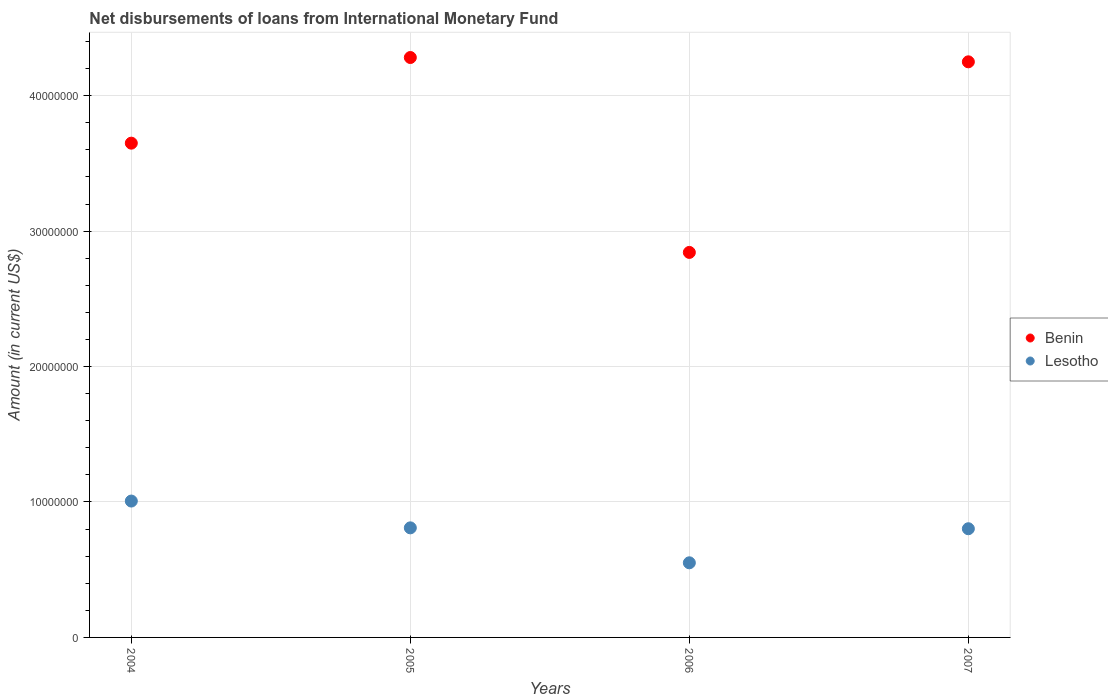Is the number of dotlines equal to the number of legend labels?
Provide a succinct answer. Yes. What is the amount of loans disbursed in Lesotho in 2006?
Ensure brevity in your answer.  5.51e+06. Across all years, what is the maximum amount of loans disbursed in Benin?
Offer a terse response. 4.28e+07. Across all years, what is the minimum amount of loans disbursed in Lesotho?
Give a very brief answer. 5.51e+06. What is the total amount of loans disbursed in Benin in the graph?
Provide a short and direct response. 1.50e+08. What is the difference between the amount of loans disbursed in Lesotho in 2004 and that in 2006?
Keep it short and to the point. 4.56e+06. What is the difference between the amount of loans disbursed in Lesotho in 2004 and the amount of loans disbursed in Benin in 2005?
Your answer should be very brief. -3.28e+07. What is the average amount of loans disbursed in Lesotho per year?
Ensure brevity in your answer.  7.92e+06. In the year 2005, what is the difference between the amount of loans disbursed in Benin and amount of loans disbursed in Lesotho?
Your answer should be very brief. 3.47e+07. In how many years, is the amount of loans disbursed in Benin greater than 42000000 US$?
Provide a succinct answer. 2. What is the ratio of the amount of loans disbursed in Lesotho in 2005 to that in 2006?
Give a very brief answer. 1.47. Is the amount of loans disbursed in Benin in 2006 less than that in 2007?
Provide a short and direct response. Yes. Is the difference between the amount of loans disbursed in Benin in 2004 and 2006 greater than the difference between the amount of loans disbursed in Lesotho in 2004 and 2006?
Offer a terse response. Yes. What is the difference between the highest and the second highest amount of loans disbursed in Benin?
Offer a terse response. 3.18e+05. What is the difference between the highest and the lowest amount of loans disbursed in Benin?
Your answer should be compact. 1.44e+07. In how many years, is the amount of loans disbursed in Benin greater than the average amount of loans disbursed in Benin taken over all years?
Give a very brief answer. 2. Is the amount of loans disbursed in Lesotho strictly greater than the amount of loans disbursed in Benin over the years?
Keep it short and to the point. No. How many dotlines are there?
Your answer should be compact. 2. What is the difference between two consecutive major ticks on the Y-axis?
Your answer should be very brief. 1.00e+07. Does the graph contain any zero values?
Your response must be concise. No. Does the graph contain grids?
Your answer should be compact. Yes. How many legend labels are there?
Your response must be concise. 2. How are the legend labels stacked?
Make the answer very short. Vertical. What is the title of the graph?
Offer a very short reply. Net disbursements of loans from International Monetary Fund. Does "Rwanda" appear as one of the legend labels in the graph?
Give a very brief answer. No. What is the label or title of the Y-axis?
Offer a terse response. Amount (in current US$). What is the Amount (in current US$) in Benin in 2004?
Ensure brevity in your answer.  3.65e+07. What is the Amount (in current US$) of Lesotho in 2004?
Offer a terse response. 1.01e+07. What is the Amount (in current US$) in Benin in 2005?
Provide a succinct answer. 4.28e+07. What is the Amount (in current US$) in Lesotho in 2005?
Your answer should be very brief. 8.09e+06. What is the Amount (in current US$) in Benin in 2006?
Provide a succinct answer. 2.84e+07. What is the Amount (in current US$) of Lesotho in 2006?
Your answer should be compact. 5.51e+06. What is the Amount (in current US$) of Benin in 2007?
Give a very brief answer. 4.25e+07. What is the Amount (in current US$) of Lesotho in 2007?
Your answer should be very brief. 8.02e+06. Across all years, what is the maximum Amount (in current US$) of Benin?
Make the answer very short. 4.28e+07. Across all years, what is the maximum Amount (in current US$) of Lesotho?
Offer a very short reply. 1.01e+07. Across all years, what is the minimum Amount (in current US$) of Benin?
Your response must be concise. 2.84e+07. Across all years, what is the minimum Amount (in current US$) of Lesotho?
Provide a short and direct response. 5.51e+06. What is the total Amount (in current US$) of Benin in the graph?
Your response must be concise. 1.50e+08. What is the total Amount (in current US$) in Lesotho in the graph?
Provide a succinct answer. 3.17e+07. What is the difference between the Amount (in current US$) in Benin in 2004 and that in 2005?
Your answer should be very brief. -6.32e+06. What is the difference between the Amount (in current US$) of Lesotho in 2004 and that in 2005?
Keep it short and to the point. 1.98e+06. What is the difference between the Amount (in current US$) of Benin in 2004 and that in 2006?
Your answer should be compact. 8.07e+06. What is the difference between the Amount (in current US$) in Lesotho in 2004 and that in 2006?
Provide a short and direct response. 4.56e+06. What is the difference between the Amount (in current US$) of Benin in 2004 and that in 2007?
Provide a succinct answer. -6.01e+06. What is the difference between the Amount (in current US$) in Lesotho in 2004 and that in 2007?
Keep it short and to the point. 2.04e+06. What is the difference between the Amount (in current US$) of Benin in 2005 and that in 2006?
Ensure brevity in your answer.  1.44e+07. What is the difference between the Amount (in current US$) of Lesotho in 2005 and that in 2006?
Keep it short and to the point. 2.58e+06. What is the difference between the Amount (in current US$) of Benin in 2005 and that in 2007?
Give a very brief answer. 3.18e+05. What is the difference between the Amount (in current US$) of Lesotho in 2005 and that in 2007?
Your answer should be compact. 6.60e+04. What is the difference between the Amount (in current US$) of Benin in 2006 and that in 2007?
Provide a short and direct response. -1.41e+07. What is the difference between the Amount (in current US$) of Lesotho in 2006 and that in 2007?
Offer a very short reply. -2.52e+06. What is the difference between the Amount (in current US$) in Benin in 2004 and the Amount (in current US$) in Lesotho in 2005?
Make the answer very short. 2.84e+07. What is the difference between the Amount (in current US$) of Benin in 2004 and the Amount (in current US$) of Lesotho in 2006?
Offer a very short reply. 3.10e+07. What is the difference between the Amount (in current US$) of Benin in 2004 and the Amount (in current US$) of Lesotho in 2007?
Make the answer very short. 2.85e+07. What is the difference between the Amount (in current US$) of Benin in 2005 and the Amount (in current US$) of Lesotho in 2006?
Provide a succinct answer. 3.73e+07. What is the difference between the Amount (in current US$) in Benin in 2005 and the Amount (in current US$) in Lesotho in 2007?
Make the answer very short. 3.48e+07. What is the difference between the Amount (in current US$) of Benin in 2006 and the Amount (in current US$) of Lesotho in 2007?
Make the answer very short. 2.04e+07. What is the average Amount (in current US$) in Benin per year?
Your answer should be compact. 3.76e+07. What is the average Amount (in current US$) in Lesotho per year?
Your answer should be very brief. 7.92e+06. In the year 2004, what is the difference between the Amount (in current US$) of Benin and Amount (in current US$) of Lesotho?
Make the answer very short. 2.64e+07. In the year 2005, what is the difference between the Amount (in current US$) in Benin and Amount (in current US$) in Lesotho?
Offer a terse response. 3.47e+07. In the year 2006, what is the difference between the Amount (in current US$) of Benin and Amount (in current US$) of Lesotho?
Ensure brevity in your answer.  2.29e+07. In the year 2007, what is the difference between the Amount (in current US$) in Benin and Amount (in current US$) in Lesotho?
Provide a succinct answer. 3.45e+07. What is the ratio of the Amount (in current US$) of Benin in 2004 to that in 2005?
Your answer should be compact. 0.85. What is the ratio of the Amount (in current US$) of Lesotho in 2004 to that in 2005?
Make the answer very short. 1.24. What is the ratio of the Amount (in current US$) in Benin in 2004 to that in 2006?
Offer a very short reply. 1.28. What is the ratio of the Amount (in current US$) in Lesotho in 2004 to that in 2006?
Keep it short and to the point. 1.83. What is the ratio of the Amount (in current US$) in Benin in 2004 to that in 2007?
Make the answer very short. 0.86. What is the ratio of the Amount (in current US$) in Lesotho in 2004 to that in 2007?
Your answer should be compact. 1.25. What is the ratio of the Amount (in current US$) in Benin in 2005 to that in 2006?
Ensure brevity in your answer.  1.51. What is the ratio of the Amount (in current US$) of Lesotho in 2005 to that in 2006?
Provide a succinct answer. 1.47. What is the ratio of the Amount (in current US$) of Benin in 2005 to that in 2007?
Ensure brevity in your answer.  1.01. What is the ratio of the Amount (in current US$) in Lesotho in 2005 to that in 2007?
Give a very brief answer. 1.01. What is the ratio of the Amount (in current US$) in Benin in 2006 to that in 2007?
Make the answer very short. 0.67. What is the ratio of the Amount (in current US$) in Lesotho in 2006 to that in 2007?
Offer a terse response. 0.69. What is the difference between the highest and the second highest Amount (in current US$) in Benin?
Offer a very short reply. 3.18e+05. What is the difference between the highest and the second highest Amount (in current US$) of Lesotho?
Your answer should be very brief. 1.98e+06. What is the difference between the highest and the lowest Amount (in current US$) of Benin?
Provide a succinct answer. 1.44e+07. What is the difference between the highest and the lowest Amount (in current US$) of Lesotho?
Provide a short and direct response. 4.56e+06. 